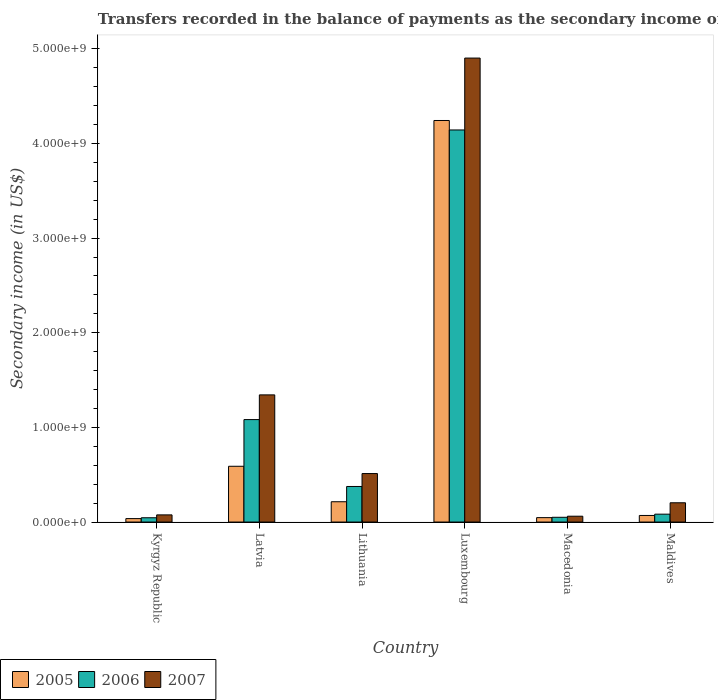Are the number of bars on each tick of the X-axis equal?
Keep it short and to the point. Yes. How many bars are there on the 4th tick from the left?
Your answer should be compact. 3. How many bars are there on the 4th tick from the right?
Give a very brief answer. 3. What is the label of the 6th group of bars from the left?
Offer a very short reply. Maldives. In how many cases, is the number of bars for a given country not equal to the number of legend labels?
Offer a terse response. 0. What is the secondary income of in 2006 in Luxembourg?
Offer a terse response. 4.14e+09. Across all countries, what is the maximum secondary income of in 2006?
Your response must be concise. 4.14e+09. Across all countries, what is the minimum secondary income of in 2005?
Offer a terse response. 3.63e+07. In which country was the secondary income of in 2005 maximum?
Provide a short and direct response. Luxembourg. In which country was the secondary income of in 2007 minimum?
Provide a short and direct response. Macedonia. What is the total secondary income of in 2005 in the graph?
Give a very brief answer. 5.20e+09. What is the difference between the secondary income of in 2006 in Macedonia and that in Maldives?
Your response must be concise. -3.30e+07. What is the difference between the secondary income of in 2007 in Macedonia and the secondary income of in 2006 in Kyrgyz Republic?
Offer a terse response. 1.63e+07. What is the average secondary income of in 2005 per country?
Offer a terse response. 8.67e+08. What is the difference between the secondary income of of/in 2007 and secondary income of of/in 2005 in Kyrgyz Republic?
Give a very brief answer. 3.93e+07. What is the ratio of the secondary income of in 2007 in Latvia to that in Maldives?
Provide a succinct answer. 6.6. What is the difference between the highest and the second highest secondary income of in 2005?
Ensure brevity in your answer.  3.75e+08. What is the difference between the highest and the lowest secondary income of in 2005?
Give a very brief answer. 4.21e+09. In how many countries, is the secondary income of in 2005 greater than the average secondary income of in 2005 taken over all countries?
Provide a succinct answer. 1. What does the 2nd bar from the left in Maldives represents?
Your answer should be compact. 2006. How many bars are there?
Offer a terse response. 18. How many countries are there in the graph?
Give a very brief answer. 6. Are the values on the major ticks of Y-axis written in scientific E-notation?
Your response must be concise. Yes. Does the graph contain any zero values?
Your answer should be very brief. No. Does the graph contain grids?
Provide a succinct answer. No. Where does the legend appear in the graph?
Keep it short and to the point. Bottom left. How are the legend labels stacked?
Make the answer very short. Horizontal. What is the title of the graph?
Offer a very short reply. Transfers recorded in the balance of payments as the secondary income of a country. What is the label or title of the Y-axis?
Provide a succinct answer. Secondary income (in US$). What is the Secondary income (in US$) of 2005 in Kyrgyz Republic?
Make the answer very short. 3.63e+07. What is the Secondary income (in US$) in 2006 in Kyrgyz Republic?
Your answer should be compact. 4.53e+07. What is the Secondary income (in US$) of 2007 in Kyrgyz Republic?
Your answer should be compact. 7.56e+07. What is the Secondary income (in US$) in 2005 in Latvia?
Your answer should be compact. 5.89e+08. What is the Secondary income (in US$) in 2006 in Latvia?
Give a very brief answer. 1.08e+09. What is the Secondary income (in US$) in 2007 in Latvia?
Provide a short and direct response. 1.34e+09. What is the Secondary income (in US$) in 2005 in Lithuania?
Your answer should be compact. 2.14e+08. What is the Secondary income (in US$) in 2006 in Lithuania?
Offer a terse response. 3.76e+08. What is the Secondary income (in US$) in 2007 in Lithuania?
Give a very brief answer. 5.12e+08. What is the Secondary income (in US$) in 2005 in Luxembourg?
Offer a very short reply. 4.24e+09. What is the Secondary income (in US$) of 2006 in Luxembourg?
Keep it short and to the point. 4.14e+09. What is the Secondary income (in US$) of 2007 in Luxembourg?
Offer a very short reply. 4.90e+09. What is the Secondary income (in US$) of 2005 in Macedonia?
Your answer should be compact. 4.65e+07. What is the Secondary income (in US$) of 2006 in Macedonia?
Your answer should be very brief. 5.01e+07. What is the Secondary income (in US$) of 2007 in Macedonia?
Offer a terse response. 6.16e+07. What is the Secondary income (in US$) of 2005 in Maldives?
Make the answer very short. 6.95e+07. What is the Secondary income (in US$) of 2006 in Maldives?
Provide a succinct answer. 8.32e+07. What is the Secondary income (in US$) in 2007 in Maldives?
Your answer should be compact. 2.04e+08. Across all countries, what is the maximum Secondary income (in US$) in 2005?
Give a very brief answer. 4.24e+09. Across all countries, what is the maximum Secondary income (in US$) of 2006?
Provide a succinct answer. 4.14e+09. Across all countries, what is the maximum Secondary income (in US$) of 2007?
Your answer should be compact. 4.90e+09. Across all countries, what is the minimum Secondary income (in US$) of 2005?
Your answer should be very brief. 3.63e+07. Across all countries, what is the minimum Secondary income (in US$) in 2006?
Keep it short and to the point. 4.53e+07. Across all countries, what is the minimum Secondary income (in US$) of 2007?
Your answer should be very brief. 6.16e+07. What is the total Secondary income (in US$) of 2005 in the graph?
Give a very brief answer. 5.20e+09. What is the total Secondary income (in US$) in 2006 in the graph?
Offer a very short reply. 5.78e+09. What is the total Secondary income (in US$) of 2007 in the graph?
Ensure brevity in your answer.  7.10e+09. What is the difference between the Secondary income (in US$) in 2005 in Kyrgyz Republic and that in Latvia?
Provide a short and direct response. -5.53e+08. What is the difference between the Secondary income (in US$) of 2006 in Kyrgyz Republic and that in Latvia?
Make the answer very short. -1.04e+09. What is the difference between the Secondary income (in US$) in 2007 in Kyrgyz Republic and that in Latvia?
Ensure brevity in your answer.  -1.27e+09. What is the difference between the Secondary income (in US$) in 2005 in Kyrgyz Republic and that in Lithuania?
Offer a very short reply. -1.78e+08. What is the difference between the Secondary income (in US$) of 2006 in Kyrgyz Republic and that in Lithuania?
Provide a short and direct response. -3.31e+08. What is the difference between the Secondary income (in US$) in 2007 in Kyrgyz Republic and that in Lithuania?
Keep it short and to the point. -4.37e+08. What is the difference between the Secondary income (in US$) of 2005 in Kyrgyz Republic and that in Luxembourg?
Provide a succinct answer. -4.21e+09. What is the difference between the Secondary income (in US$) in 2006 in Kyrgyz Republic and that in Luxembourg?
Offer a terse response. -4.10e+09. What is the difference between the Secondary income (in US$) in 2007 in Kyrgyz Republic and that in Luxembourg?
Keep it short and to the point. -4.83e+09. What is the difference between the Secondary income (in US$) in 2005 in Kyrgyz Republic and that in Macedonia?
Offer a terse response. -1.02e+07. What is the difference between the Secondary income (in US$) in 2006 in Kyrgyz Republic and that in Macedonia?
Offer a terse response. -4.86e+06. What is the difference between the Secondary income (in US$) in 2007 in Kyrgyz Republic and that in Macedonia?
Your response must be concise. 1.40e+07. What is the difference between the Secondary income (in US$) in 2005 in Kyrgyz Republic and that in Maldives?
Your answer should be very brief. -3.32e+07. What is the difference between the Secondary income (in US$) of 2006 in Kyrgyz Republic and that in Maldives?
Your answer should be compact. -3.79e+07. What is the difference between the Secondary income (in US$) in 2007 in Kyrgyz Republic and that in Maldives?
Make the answer very short. -1.28e+08. What is the difference between the Secondary income (in US$) in 2005 in Latvia and that in Lithuania?
Give a very brief answer. 3.75e+08. What is the difference between the Secondary income (in US$) in 2006 in Latvia and that in Lithuania?
Make the answer very short. 7.07e+08. What is the difference between the Secondary income (in US$) in 2007 in Latvia and that in Lithuania?
Your answer should be compact. 8.31e+08. What is the difference between the Secondary income (in US$) in 2005 in Latvia and that in Luxembourg?
Your answer should be very brief. -3.65e+09. What is the difference between the Secondary income (in US$) of 2006 in Latvia and that in Luxembourg?
Offer a very short reply. -3.06e+09. What is the difference between the Secondary income (in US$) of 2007 in Latvia and that in Luxembourg?
Your answer should be very brief. -3.56e+09. What is the difference between the Secondary income (in US$) of 2005 in Latvia and that in Macedonia?
Provide a succinct answer. 5.43e+08. What is the difference between the Secondary income (in US$) of 2006 in Latvia and that in Macedonia?
Provide a short and direct response. 1.03e+09. What is the difference between the Secondary income (in US$) in 2007 in Latvia and that in Macedonia?
Ensure brevity in your answer.  1.28e+09. What is the difference between the Secondary income (in US$) of 2005 in Latvia and that in Maldives?
Offer a terse response. 5.20e+08. What is the difference between the Secondary income (in US$) in 2006 in Latvia and that in Maldives?
Offer a terse response. 9.99e+08. What is the difference between the Secondary income (in US$) in 2007 in Latvia and that in Maldives?
Provide a short and direct response. 1.14e+09. What is the difference between the Secondary income (in US$) in 2005 in Lithuania and that in Luxembourg?
Provide a short and direct response. -4.03e+09. What is the difference between the Secondary income (in US$) in 2006 in Lithuania and that in Luxembourg?
Your response must be concise. -3.77e+09. What is the difference between the Secondary income (in US$) in 2007 in Lithuania and that in Luxembourg?
Ensure brevity in your answer.  -4.39e+09. What is the difference between the Secondary income (in US$) in 2005 in Lithuania and that in Macedonia?
Your response must be concise. 1.68e+08. What is the difference between the Secondary income (in US$) in 2006 in Lithuania and that in Macedonia?
Make the answer very short. 3.26e+08. What is the difference between the Secondary income (in US$) in 2007 in Lithuania and that in Macedonia?
Make the answer very short. 4.51e+08. What is the difference between the Secondary income (in US$) in 2005 in Lithuania and that in Maldives?
Make the answer very short. 1.45e+08. What is the difference between the Secondary income (in US$) in 2006 in Lithuania and that in Maldives?
Ensure brevity in your answer.  2.93e+08. What is the difference between the Secondary income (in US$) of 2007 in Lithuania and that in Maldives?
Your answer should be compact. 3.09e+08. What is the difference between the Secondary income (in US$) in 2005 in Luxembourg and that in Macedonia?
Your response must be concise. 4.20e+09. What is the difference between the Secondary income (in US$) of 2006 in Luxembourg and that in Macedonia?
Your answer should be very brief. 4.09e+09. What is the difference between the Secondary income (in US$) in 2007 in Luxembourg and that in Macedonia?
Your answer should be very brief. 4.84e+09. What is the difference between the Secondary income (in US$) of 2005 in Luxembourg and that in Maldives?
Your answer should be very brief. 4.17e+09. What is the difference between the Secondary income (in US$) of 2006 in Luxembourg and that in Maldives?
Your answer should be compact. 4.06e+09. What is the difference between the Secondary income (in US$) of 2007 in Luxembourg and that in Maldives?
Offer a terse response. 4.70e+09. What is the difference between the Secondary income (in US$) in 2005 in Macedonia and that in Maldives?
Your answer should be compact. -2.30e+07. What is the difference between the Secondary income (in US$) of 2006 in Macedonia and that in Maldives?
Your response must be concise. -3.30e+07. What is the difference between the Secondary income (in US$) of 2007 in Macedonia and that in Maldives?
Ensure brevity in your answer.  -1.42e+08. What is the difference between the Secondary income (in US$) of 2005 in Kyrgyz Republic and the Secondary income (in US$) of 2006 in Latvia?
Provide a short and direct response. -1.05e+09. What is the difference between the Secondary income (in US$) of 2005 in Kyrgyz Republic and the Secondary income (in US$) of 2007 in Latvia?
Keep it short and to the point. -1.31e+09. What is the difference between the Secondary income (in US$) in 2006 in Kyrgyz Republic and the Secondary income (in US$) in 2007 in Latvia?
Ensure brevity in your answer.  -1.30e+09. What is the difference between the Secondary income (in US$) of 2005 in Kyrgyz Republic and the Secondary income (in US$) of 2006 in Lithuania?
Make the answer very short. -3.39e+08. What is the difference between the Secondary income (in US$) of 2005 in Kyrgyz Republic and the Secondary income (in US$) of 2007 in Lithuania?
Offer a very short reply. -4.76e+08. What is the difference between the Secondary income (in US$) of 2006 in Kyrgyz Republic and the Secondary income (in US$) of 2007 in Lithuania?
Offer a terse response. -4.67e+08. What is the difference between the Secondary income (in US$) of 2005 in Kyrgyz Republic and the Secondary income (in US$) of 2006 in Luxembourg?
Make the answer very short. -4.11e+09. What is the difference between the Secondary income (in US$) in 2005 in Kyrgyz Republic and the Secondary income (in US$) in 2007 in Luxembourg?
Your answer should be compact. -4.87e+09. What is the difference between the Secondary income (in US$) in 2006 in Kyrgyz Republic and the Secondary income (in US$) in 2007 in Luxembourg?
Offer a very short reply. -4.86e+09. What is the difference between the Secondary income (in US$) in 2005 in Kyrgyz Republic and the Secondary income (in US$) in 2006 in Macedonia?
Your answer should be compact. -1.38e+07. What is the difference between the Secondary income (in US$) in 2005 in Kyrgyz Republic and the Secondary income (in US$) in 2007 in Macedonia?
Provide a succinct answer. -2.53e+07. What is the difference between the Secondary income (in US$) of 2006 in Kyrgyz Republic and the Secondary income (in US$) of 2007 in Macedonia?
Provide a succinct answer. -1.63e+07. What is the difference between the Secondary income (in US$) in 2005 in Kyrgyz Republic and the Secondary income (in US$) in 2006 in Maldives?
Provide a short and direct response. -4.69e+07. What is the difference between the Secondary income (in US$) in 2005 in Kyrgyz Republic and the Secondary income (in US$) in 2007 in Maldives?
Provide a short and direct response. -1.67e+08. What is the difference between the Secondary income (in US$) of 2006 in Kyrgyz Republic and the Secondary income (in US$) of 2007 in Maldives?
Offer a terse response. -1.58e+08. What is the difference between the Secondary income (in US$) of 2005 in Latvia and the Secondary income (in US$) of 2006 in Lithuania?
Give a very brief answer. 2.13e+08. What is the difference between the Secondary income (in US$) of 2005 in Latvia and the Secondary income (in US$) of 2007 in Lithuania?
Offer a very short reply. 7.68e+07. What is the difference between the Secondary income (in US$) in 2006 in Latvia and the Secondary income (in US$) in 2007 in Lithuania?
Offer a very short reply. 5.70e+08. What is the difference between the Secondary income (in US$) of 2005 in Latvia and the Secondary income (in US$) of 2006 in Luxembourg?
Give a very brief answer. -3.55e+09. What is the difference between the Secondary income (in US$) in 2005 in Latvia and the Secondary income (in US$) in 2007 in Luxembourg?
Provide a succinct answer. -4.31e+09. What is the difference between the Secondary income (in US$) of 2006 in Latvia and the Secondary income (in US$) of 2007 in Luxembourg?
Provide a short and direct response. -3.82e+09. What is the difference between the Secondary income (in US$) in 2005 in Latvia and the Secondary income (in US$) in 2006 in Macedonia?
Your answer should be very brief. 5.39e+08. What is the difference between the Secondary income (in US$) of 2005 in Latvia and the Secondary income (in US$) of 2007 in Macedonia?
Give a very brief answer. 5.28e+08. What is the difference between the Secondary income (in US$) in 2006 in Latvia and the Secondary income (in US$) in 2007 in Macedonia?
Ensure brevity in your answer.  1.02e+09. What is the difference between the Secondary income (in US$) in 2005 in Latvia and the Secondary income (in US$) in 2006 in Maldives?
Provide a short and direct response. 5.06e+08. What is the difference between the Secondary income (in US$) in 2005 in Latvia and the Secondary income (in US$) in 2007 in Maldives?
Your answer should be compact. 3.86e+08. What is the difference between the Secondary income (in US$) in 2006 in Latvia and the Secondary income (in US$) in 2007 in Maldives?
Your response must be concise. 8.79e+08. What is the difference between the Secondary income (in US$) in 2005 in Lithuania and the Secondary income (in US$) in 2006 in Luxembourg?
Your answer should be compact. -3.93e+09. What is the difference between the Secondary income (in US$) of 2005 in Lithuania and the Secondary income (in US$) of 2007 in Luxembourg?
Your response must be concise. -4.69e+09. What is the difference between the Secondary income (in US$) of 2006 in Lithuania and the Secondary income (in US$) of 2007 in Luxembourg?
Your answer should be compact. -4.53e+09. What is the difference between the Secondary income (in US$) in 2005 in Lithuania and the Secondary income (in US$) in 2006 in Macedonia?
Your response must be concise. 1.64e+08. What is the difference between the Secondary income (in US$) of 2005 in Lithuania and the Secondary income (in US$) of 2007 in Macedonia?
Offer a terse response. 1.53e+08. What is the difference between the Secondary income (in US$) in 2006 in Lithuania and the Secondary income (in US$) in 2007 in Macedonia?
Provide a succinct answer. 3.14e+08. What is the difference between the Secondary income (in US$) of 2005 in Lithuania and the Secondary income (in US$) of 2006 in Maldives?
Your response must be concise. 1.31e+08. What is the difference between the Secondary income (in US$) in 2005 in Lithuania and the Secondary income (in US$) in 2007 in Maldives?
Your response must be concise. 1.09e+07. What is the difference between the Secondary income (in US$) of 2006 in Lithuania and the Secondary income (in US$) of 2007 in Maldives?
Your answer should be very brief. 1.72e+08. What is the difference between the Secondary income (in US$) in 2005 in Luxembourg and the Secondary income (in US$) in 2006 in Macedonia?
Provide a short and direct response. 4.19e+09. What is the difference between the Secondary income (in US$) in 2005 in Luxembourg and the Secondary income (in US$) in 2007 in Macedonia?
Make the answer very short. 4.18e+09. What is the difference between the Secondary income (in US$) in 2006 in Luxembourg and the Secondary income (in US$) in 2007 in Macedonia?
Your response must be concise. 4.08e+09. What is the difference between the Secondary income (in US$) of 2005 in Luxembourg and the Secondary income (in US$) of 2006 in Maldives?
Offer a terse response. 4.16e+09. What is the difference between the Secondary income (in US$) of 2005 in Luxembourg and the Secondary income (in US$) of 2007 in Maldives?
Offer a very short reply. 4.04e+09. What is the difference between the Secondary income (in US$) of 2006 in Luxembourg and the Secondary income (in US$) of 2007 in Maldives?
Your response must be concise. 3.94e+09. What is the difference between the Secondary income (in US$) of 2005 in Macedonia and the Secondary income (in US$) of 2006 in Maldives?
Keep it short and to the point. -3.67e+07. What is the difference between the Secondary income (in US$) of 2005 in Macedonia and the Secondary income (in US$) of 2007 in Maldives?
Your answer should be compact. -1.57e+08. What is the difference between the Secondary income (in US$) of 2006 in Macedonia and the Secondary income (in US$) of 2007 in Maldives?
Your answer should be very brief. -1.53e+08. What is the average Secondary income (in US$) in 2005 per country?
Make the answer very short. 8.67e+08. What is the average Secondary income (in US$) of 2006 per country?
Offer a terse response. 9.63e+08. What is the average Secondary income (in US$) of 2007 per country?
Keep it short and to the point. 1.18e+09. What is the difference between the Secondary income (in US$) of 2005 and Secondary income (in US$) of 2006 in Kyrgyz Republic?
Provide a short and direct response. -8.99e+06. What is the difference between the Secondary income (in US$) in 2005 and Secondary income (in US$) in 2007 in Kyrgyz Republic?
Your answer should be very brief. -3.93e+07. What is the difference between the Secondary income (in US$) of 2006 and Secondary income (in US$) of 2007 in Kyrgyz Republic?
Offer a terse response. -3.03e+07. What is the difference between the Secondary income (in US$) of 2005 and Secondary income (in US$) of 2006 in Latvia?
Keep it short and to the point. -4.93e+08. What is the difference between the Secondary income (in US$) in 2005 and Secondary income (in US$) in 2007 in Latvia?
Offer a terse response. -7.54e+08. What is the difference between the Secondary income (in US$) in 2006 and Secondary income (in US$) in 2007 in Latvia?
Keep it short and to the point. -2.61e+08. What is the difference between the Secondary income (in US$) of 2005 and Secondary income (in US$) of 2006 in Lithuania?
Provide a short and direct response. -1.61e+08. What is the difference between the Secondary income (in US$) in 2005 and Secondary income (in US$) in 2007 in Lithuania?
Offer a terse response. -2.98e+08. What is the difference between the Secondary income (in US$) in 2006 and Secondary income (in US$) in 2007 in Lithuania?
Your answer should be very brief. -1.37e+08. What is the difference between the Secondary income (in US$) in 2005 and Secondary income (in US$) in 2006 in Luxembourg?
Your answer should be very brief. 1.00e+08. What is the difference between the Secondary income (in US$) of 2005 and Secondary income (in US$) of 2007 in Luxembourg?
Your answer should be very brief. -6.60e+08. What is the difference between the Secondary income (in US$) in 2006 and Secondary income (in US$) in 2007 in Luxembourg?
Your response must be concise. -7.60e+08. What is the difference between the Secondary income (in US$) in 2005 and Secondary income (in US$) in 2006 in Macedonia?
Make the answer very short. -3.63e+06. What is the difference between the Secondary income (in US$) in 2005 and Secondary income (in US$) in 2007 in Macedonia?
Give a very brief answer. -1.51e+07. What is the difference between the Secondary income (in US$) in 2006 and Secondary income (in US$) in 2007 in Macedonia?
Offer a terse response. -1.14e+07. What is the difference between the Secondary income (in US$) of 2005 and Secondary income (in US$) of 2006 in Maldives?
Your response must be concise. -1.36e+07. What is the difference between the Secondary income (in US$) in 2005 and Secondary income (in US$) in 2007 in Maldives?
Make the answer very short. -1.34e+08. What is the difference between the Secondary income (in US$) in 2006 and Secondary income (in US$) in 2007 in Maldives?
Make the answer very short. -1.20e+08. What is the ratio of the Secondary income (in US$) of 2005 in Kyrgyz Republic to that in Latvia?
Make the answer very short. 0.06. What is the ratio of the Secondary income (in US$) in 2006 in Kyrgyz Republic to that in Latvia?
Your response must be concise. 0.04. What is the ratio of the Secondary income (in US$) of 2007 in Kyrgyz Republic to that in Latvia?
Keep it short and to the point. 0.06. What is the ratio of the Secondary income (in US$) of 2005 in Kyrgyz Republic to that in Lithuania?
Your response must be concise. 0.17. What is the ratio of the Secondary income (in US$) of 2006 in Kyrgyz Republic to that in Lithuania?
Your answer should be very brief. 0.12. What is the ratio of the Secondary income (in US$) in 2007 in Kyrgyz Republic to that in Lithuania?
Your response must be concise. 0.15. What is the ratio of the Secondary income (in US$) in 2005 in Kyrgyz Republic to that in Luxembourg?
Your answer should be compact. 0.01. What is the ratio of the Secondary income (in US$) of 2006 in Kyrgyz Republic to that in Luxembourg?
Provide a succinct answer. 0.01. What is the ratio of the Secondary income (in US$) in 2007 in Kyrgyz Republic to that in Luxembourg?
Offer a very short reply. 0.02. What is the ratio of the Secondary income (in US$) of 2005 in Kyrgyz Republic to that in Macedonia?
Make the answer very short. 0.78. What is the ratio of the Secondary income (in US$) in 2006 in Kyrgyz Republic to that in Macedonia?
Your answer should be compact. 0.9. What is the ratio of the Secondary income (in US$) in 2007 in Kyrgyz Republic to that in Macedonia?
Offer a very short reply. 1.23. What is the ratio of the Secondary income (in US$) in 2005 in Kyrgyz Republic to that in Maldives?
Give a very brief answer. 0.52. What is the ratio of the Secondary income (in US$) of 2006 in Kyrgyz Republic to that in Maldives?
Give a very brief answer. 0.54. What is the ratio of the Secondary income (in US$) in 2007 in Kyrgyz Republic to that in Maldives?
Keep it short and to the point. 0.37. What is the ratio of the Secondary income (in US$) in 2005 in Latvia to that in Lithuania?
Your answer should be compact. 2.75. What is the ratio of the Secondary income (in US$) of 2006 in Latvia to that in Lithuania?
Give a very brief answer. 2.88. What is the ratio of the Secondary income (in US$) in 2007 in Latvia to that in Lithuania?
Provide a short and direct response. 2.62. What is the ratio of the Secondary income (in US$) of 2005 in Latvia to that in Luxembourg?
Offer a very short reply. 0.14. What is the ratio of the Secondary income (in US$) in 2006 in Latvia to that in Luxembourg?
Provide a succinct answer. 0.26. What is the ratio of the Secondary income (in US$) in 2007 in Latvia to that in Luxembourg?
Provide a succinct answer. 0.27. What is the ratio of the Secondary income (in US$) of 2005 in Latvia to that in Macedonia?
Give a very brief answer. 12.67. What is the ratio of the Secondary income (in US$) of 2006 in Latvia to that in Macedonia?
Provide a short and direct response. 21.6. What is the ratio of the Secondary income (in US$) in 2007 in Latvia to that in Macedonia?
Ensure brevity in your answer.  21.83. What is the ratio of the Secondary income (in US$) in 2005 in Latvia to that in Maldives?
Provide a succinct answer. 8.48. What is the ratio of the Secondary income (in US$) in 2006 in Latvia to that in Maldives?
Your response must be concise. 13.02. What is the ratio of the Secondary income (in US$) in 2007 in Latvia to that in Maldives?
Your response must be concise. 6.6. What is the ratio of the Secondary income (in US$) of 2005 in Lithuania to that in Luxembourg?
Offer a terse response. 0.05. What is the ratio of the Secondary income (in US$) in 2006 in Lithuania to that in Luxembourg?
Offer a terse response. 0.09. What is the ratio of the Secondary income (in US$) in 2007 in Lithuania to that in Luxembourg?
Your answer should be very brief. 0.1. What is the ratio of the Secondary income (in US$) in 2005 in Lithuania to that in Macedonia?
Your answer should be very brief. 4.61. What is the ratio of the Secondary income (in US$) in 2006 in Lithuania to that in Macedonia?
Your answer should be very brief. 7.5. What is the ratio of the Secondary income (in US$) of 2007 in Lithuania to that in Macedonia?
Offer a terse response. 8.32. What is the ratio of the Secondary income (in US$) in 2005 in Lithuania to that in Maldives?
Ensure brevity in your answer.  3.09. What is the ratio of the Secondary income (in US$) in 2006 in Lithuania to that in Maldives?
Give a very brief answer. 4.52. What is the ratio of the Secondary income (in US$) of 2007 in Lithuania to that in Maldives?
Keep it short and to the point. 2.52. What is the ratio of the Secondary income (in US$) in 2005 in Luxembourg to that in Macedonia?
Offer a very short reply. 91.26. What is the ratio of the Secondary income (in US$) in 2006 in Luxembourg to that in Macedonia?
Provide a succinct answer. 82.66. What is the ratio of the Secondary income (in US$) in 2007 in Luxembourg to that in Macedonia?
Provide a short and direct response. 79.65. What is the ratio of the Secondary income (in US$) in 2005 in Luxembourg to that in Maldives?
Ensure brevity in your answer.  61.04. What is the ratio of the Secondary income (in US$) of 2006 in Luxembourg to that in Maldives?
Offer a very short reply. 49.83. What is the ratio of the Secondary income (in US$) of 2007 in Luxembourg to that in Maldives?
Provide a short and direct response. 24.09. What is the ratio of the Secondary income (in US$) in 2005 in Macedonia to that in Maldives?
Give a very brief answer. 0.67. What is the ratio of the Secondary income (in US$) of 2006 in Macedonia to that in Maldives?
Offer a very short reply. 0.6. What is the ratio of the Secondary income (in US$) of 2007 in Macedonia to that in Maldives?
Give a very brief answer. 0.3. What is the difference between the highest and the second highest Secondary income (in US$) of 2005?
Offer a very short reply. 3.65e+09. What is the difference between the highest and the second highest Secondary income (in US$) of 2006?
Make the answer very short. 3.06e+09. What is the difference between the highest and the second highest Secondary income (in US$) in 2007?
Give a very brief answer. 3.56e+09. What is the difference between the highest and the lowest Secondary income (in US$) of 2005?
Make the answer very short. 4.21e+09. What is the difference between the highest and the lowest Secondary income (in US$) of 2006?
Provide a short and direct response. 4.10e+09. What is the difference between the highest and the lowest Secondary income (in US$) of 2007?
Offer a terse response. 4.84e+09. 